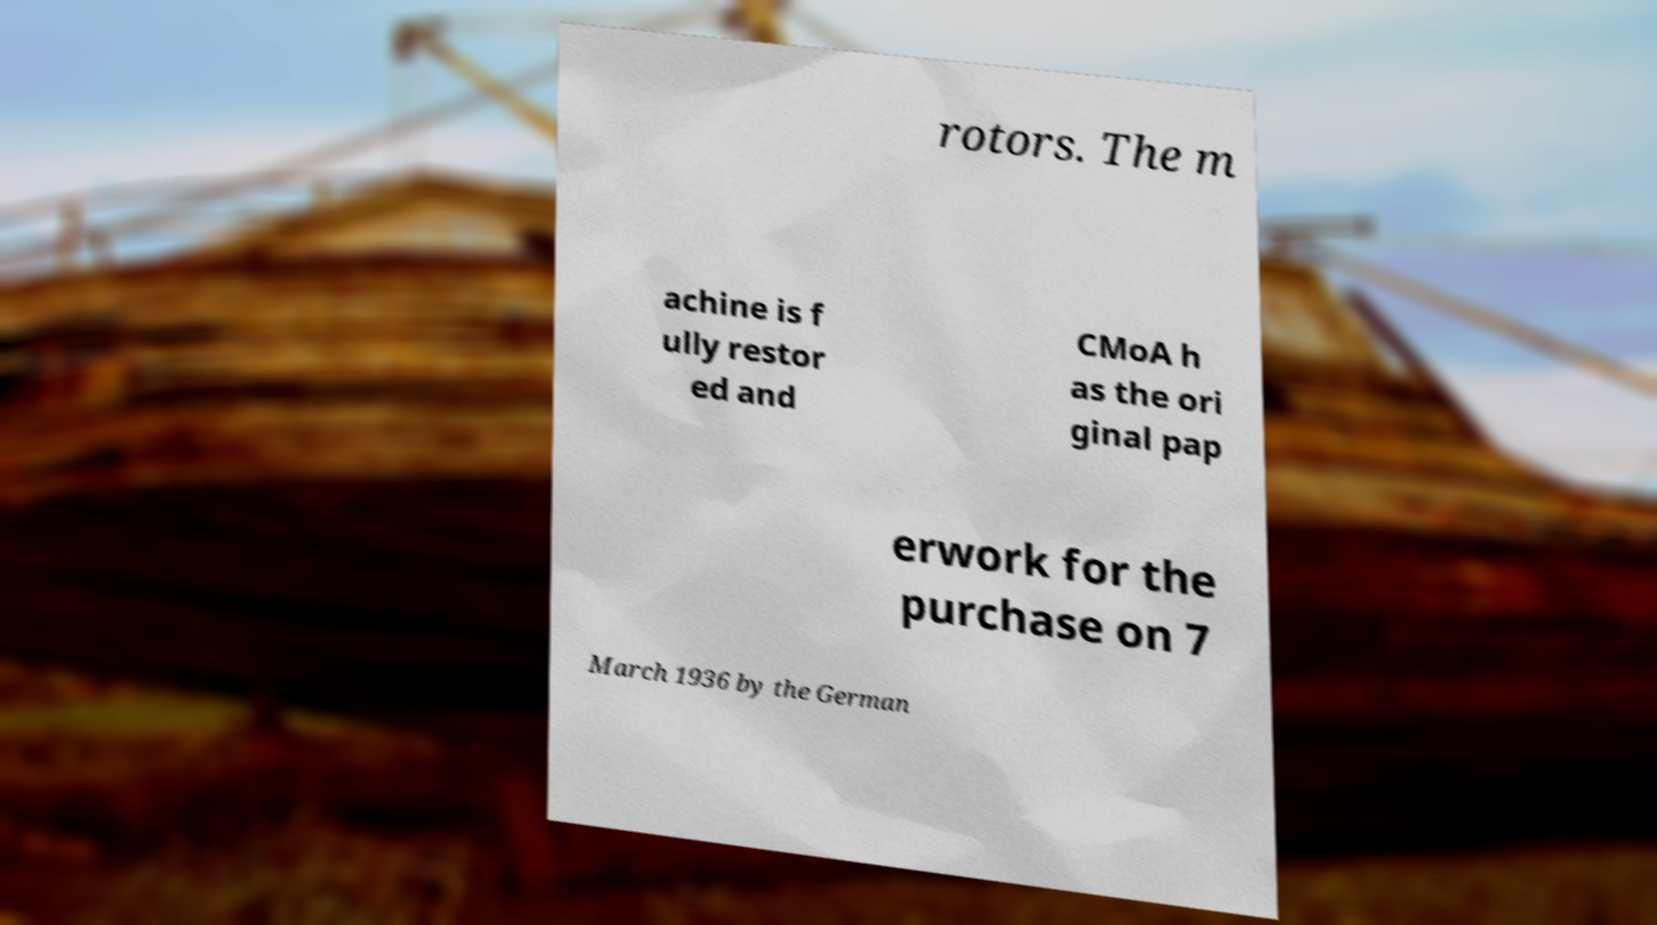Can you read and provide the text displayed in the image?This photo seems to have some interesting text. Can you extract and type it out for me? rotors. The m achine is f ully restor ed and CMoA h as the ori ginal pap erwork for the purchase on 7 March 1936 by the German 